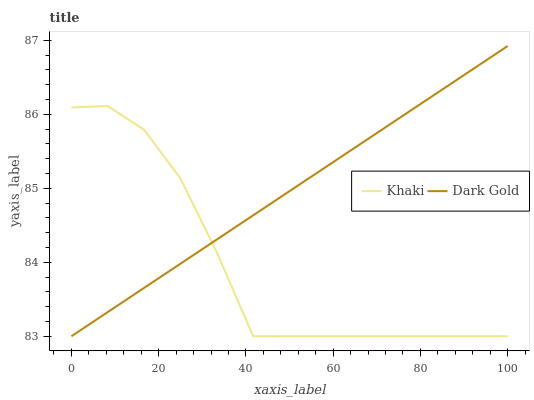Does Dark Gold have the minimum area under the curve?
Answer yes or no. No. Is Dark Gold the roughest?
Answer yes or no. No. 